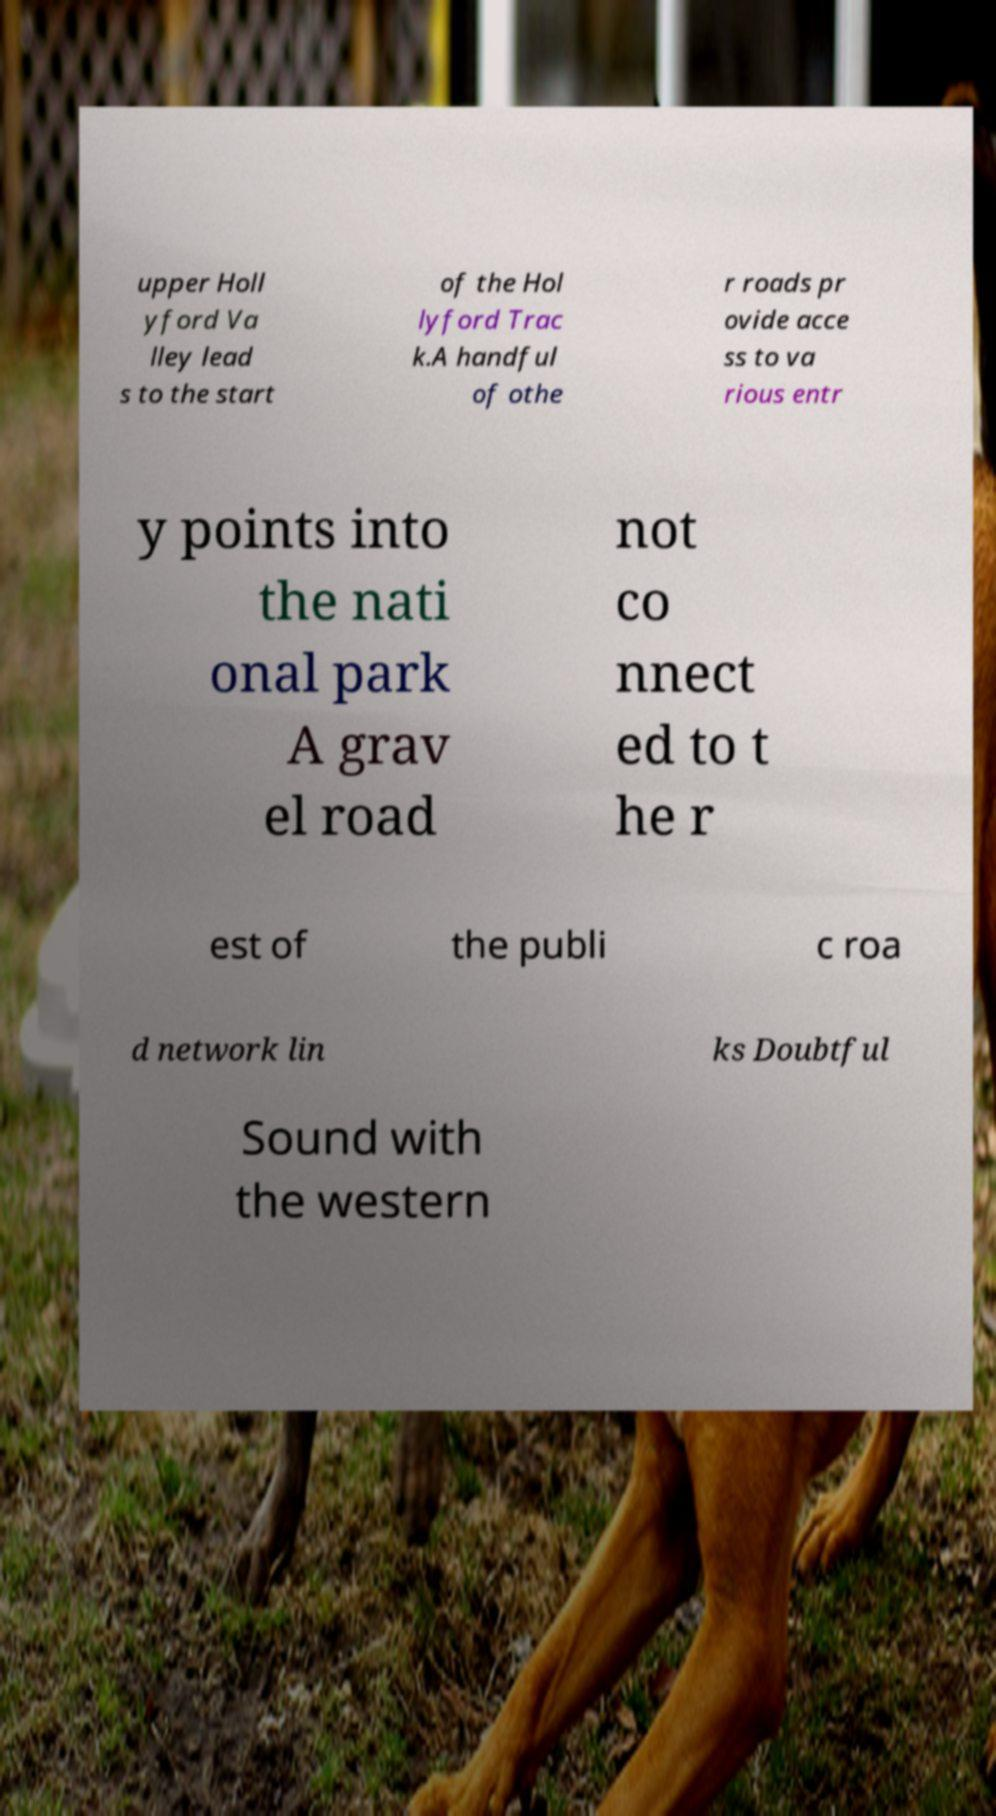Can you read and provide the text displayed in the image?This photo seems to have some interesting text. Can you extract and type it out for me? upper Holl yford Va lley lead s to the start of the Hol lyford Trac k.A handful of othe r roads pr ovide acce ss to va rious entr y points into the nati onal park A grav el road not co nnect ed to t he r est of the publi c roa d network lin ks Doubtful Sound with the western 